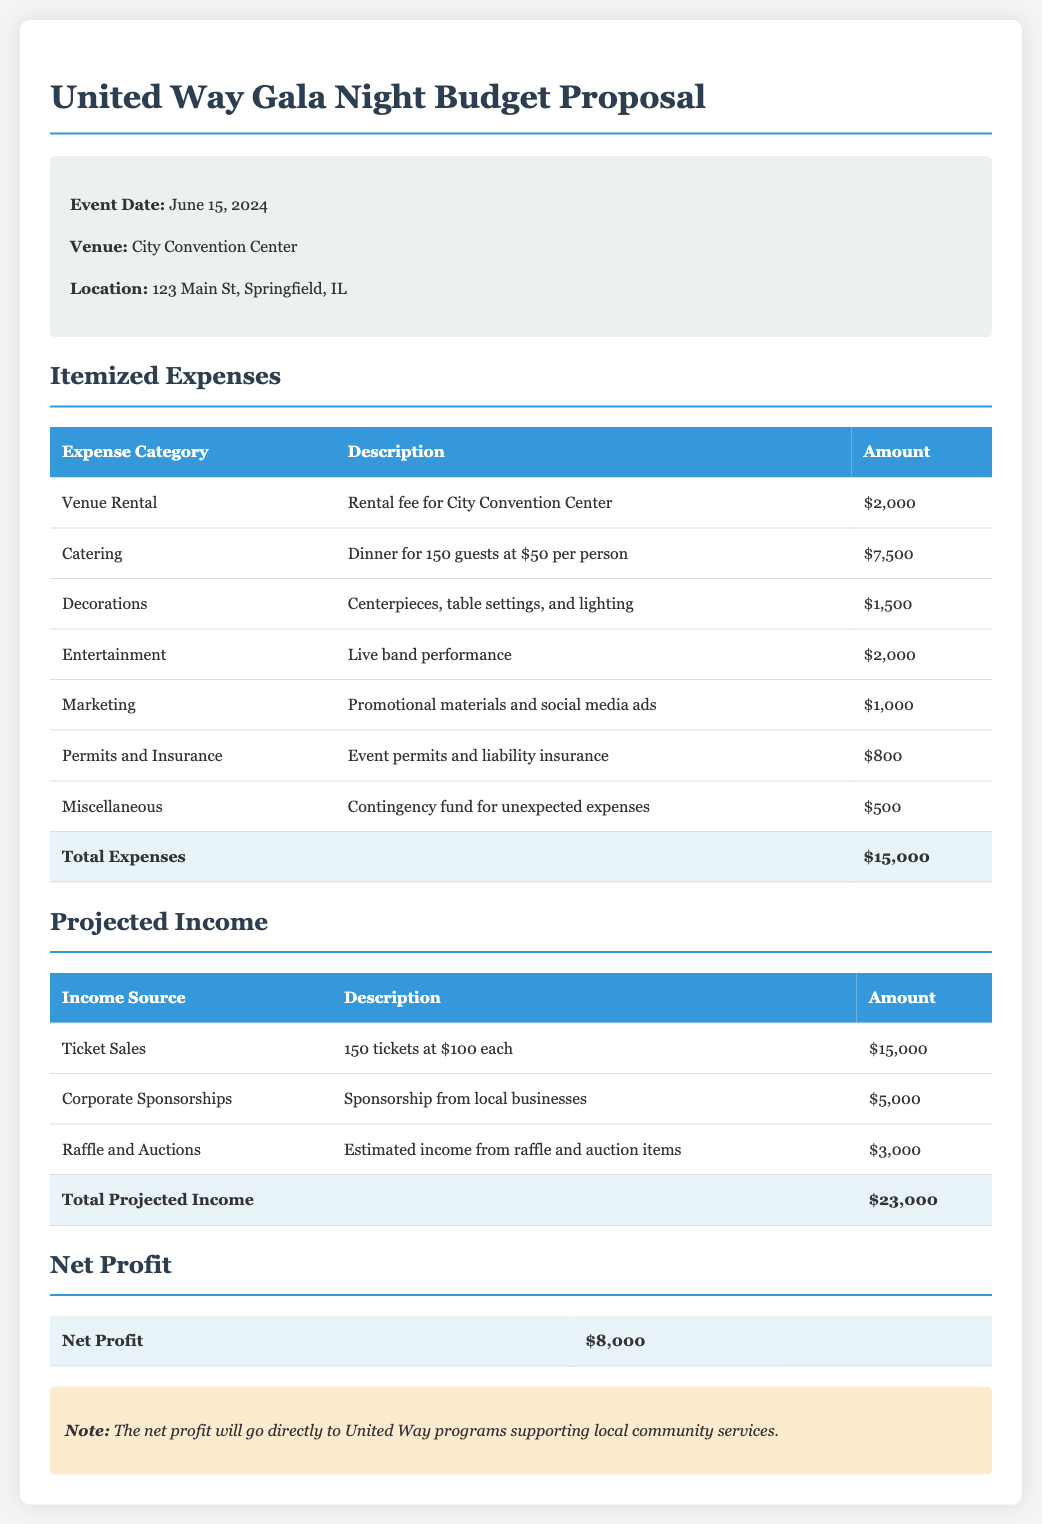What is the event date? The event date is explicitly mentioned in the document as June 15, 2024.
Answer: June 15, 2024 What is the total expense amount? The total amount for expenses is stated in the itemized expenses section, totaling $15,000.
Answer: $15,000 How many guests will be served dinner? The catering section specifies that dinner is for 150 guests.
Answer: 150 What is the income from ticket sales? The projected income section shows that ticket sales will generate $15,000.
Answer: $15,000 What is the net profit from the event? The net profit is calculated at the bottom of the budget, showing a total of $8,000.
Answer: $8,000 What is the venue for the event? The document clearly states that the venue is the City Convention Center.
Answer: City Convention Center How much money is expected from corporate sponsorships? The sponsorship section lists expected income from corporate sponsorships as $5,000.
Answer: $5,000 What is included in the decorations expense? The description in the itemized list mentions centerpieces, table settings, and lighting as part of the decorations.
Answer: Centerpieces, table settings, and lighting What will the net profit support? The note at the end of the document states that the net profit will support United Way programs.
Answer: United Way programs 